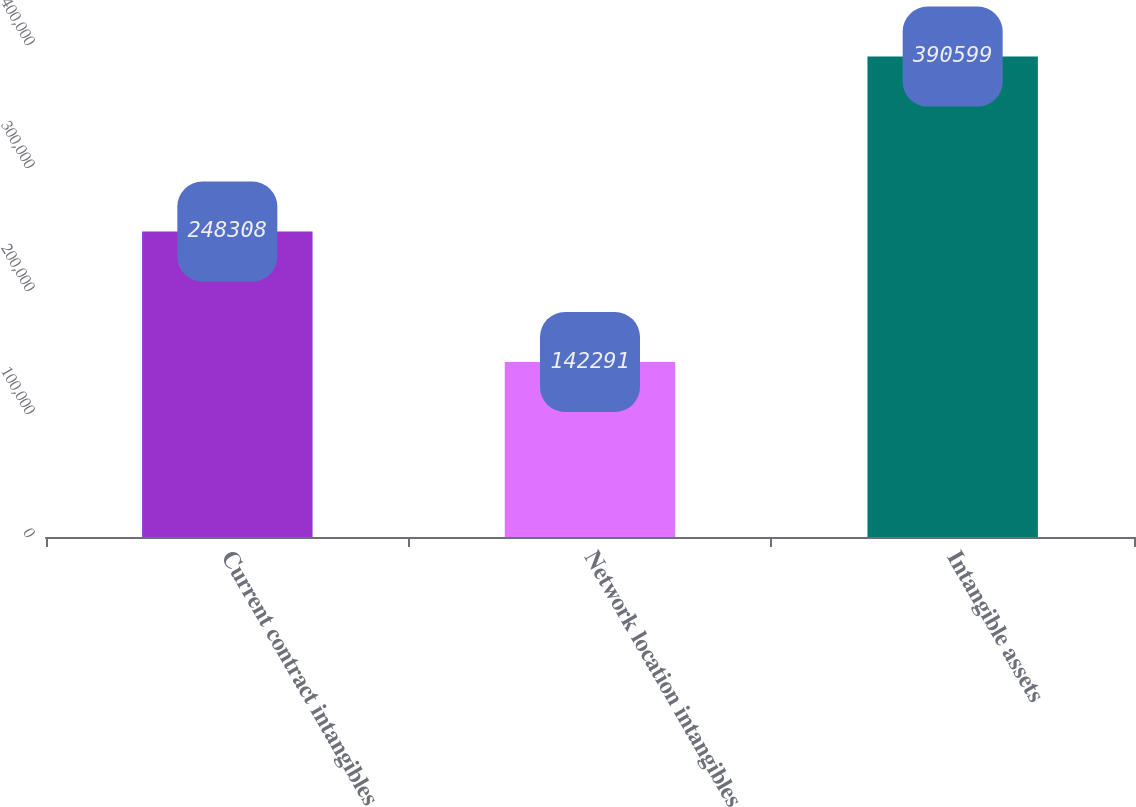<chart> <loc_0><loc_0><loc_500><loc_500><bar_chart><fcel>Current contract intangibles<fcel>Network location intangibles<fcel>Intangible assets<nl><fcel>248308<fcel>142291<fcel>390599<nl></chart> 